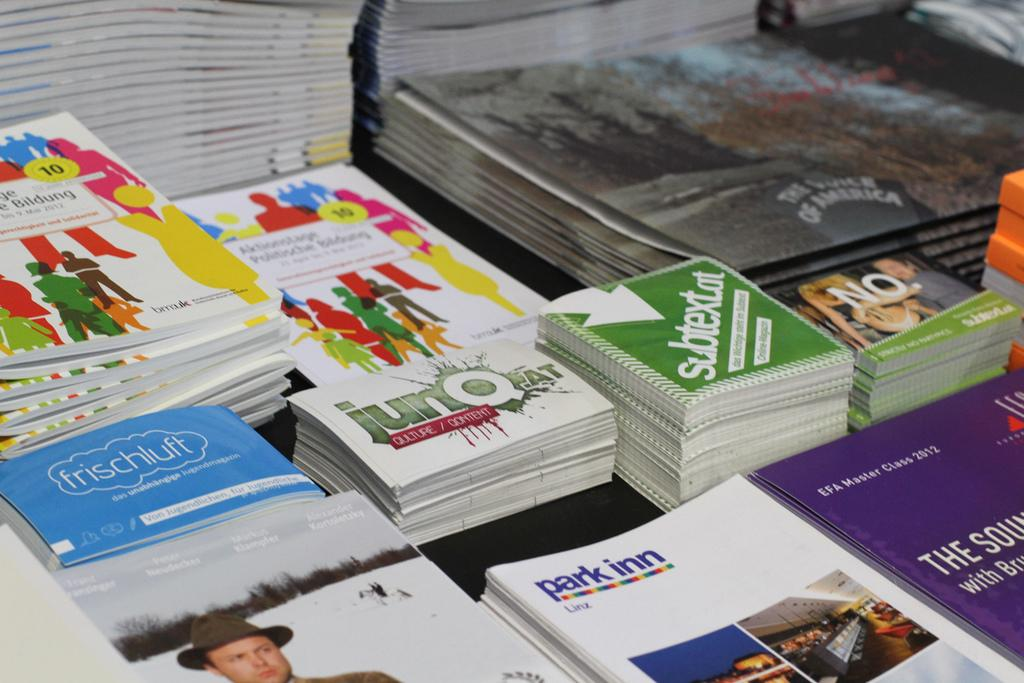Provide a one-sentence caption for the provided image. A table is covered with pamphlets from park inn, frischluft, and other things. 